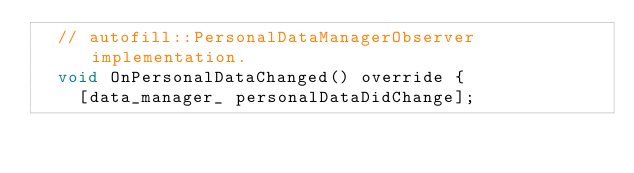<code> <loc_0><loc_0><loc_500><loc_500><_ObjectiveC_>  // autofill::PersonalDataManagerObserver implementation.
  void OnPersonalDataChanged() override {
    [data_manager_ personalDataDidChange];</code> 